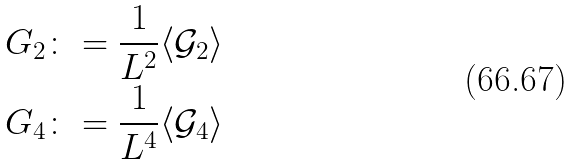Convert formula to latex. <formula><loc_0><loc_0><loc_500><loc_500>G _ { 2 } & \colon = \frac { 1 } { L ^ { 2 } } \langle \mathcal { G } _ { 2 } \rangle \\ G _ { 4 } & \colon = \frac { 1 } { L ^ { 4 } } \langle \mathcal { G } _ { 4 } \rangle</formula> 